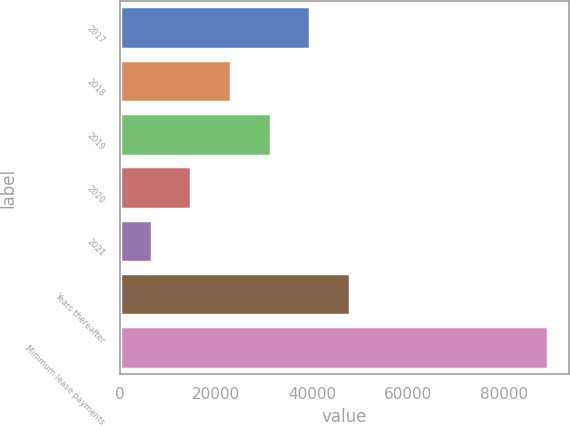<chart> <loc_0><loc_0><loc_500><loc_500><bar_chart><fcel>2017<fcel>2018<fcel>2019<fcel>2020<fcel>2021<fcel>Years thereafter<fcel>Minimum lease payments<nl><fcel>39666.2<fcel>23181.6<fcel>31423.9<fcel>14939.3<fcel>6697<fcel>47908.5<fcel>89120<nl></chart> 